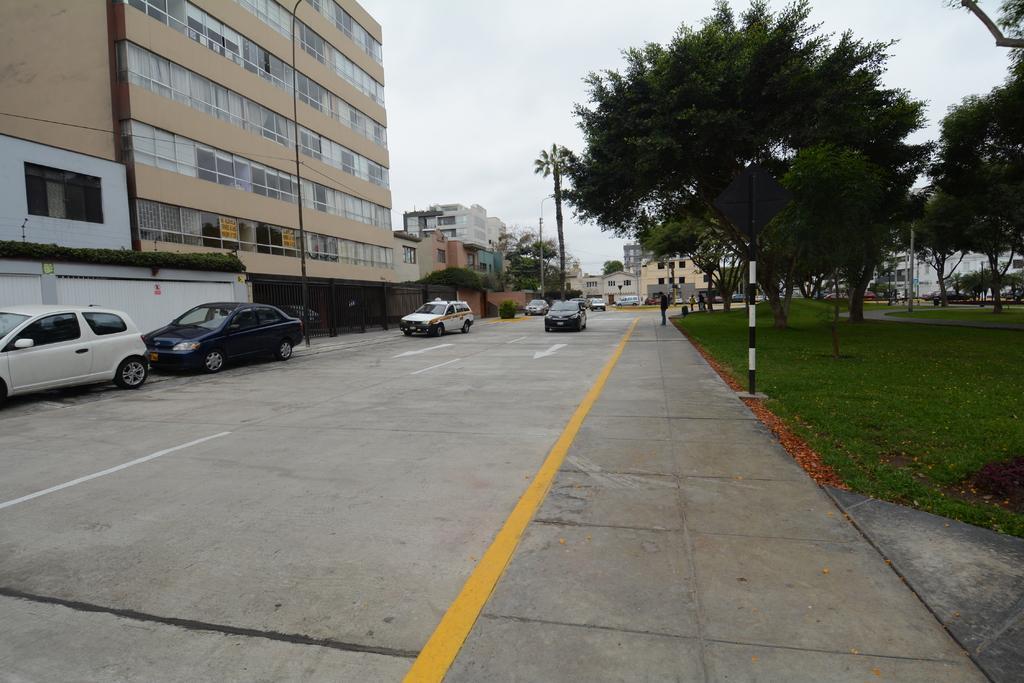Could you give a brief overview of what you see in this image? In this image we can see cars on the road. On the right side of the image, we can see grassy land, poles, trees and buildings. On the left side of the image, we can see buildings and poles. At the top of the image, we can see the sky. 